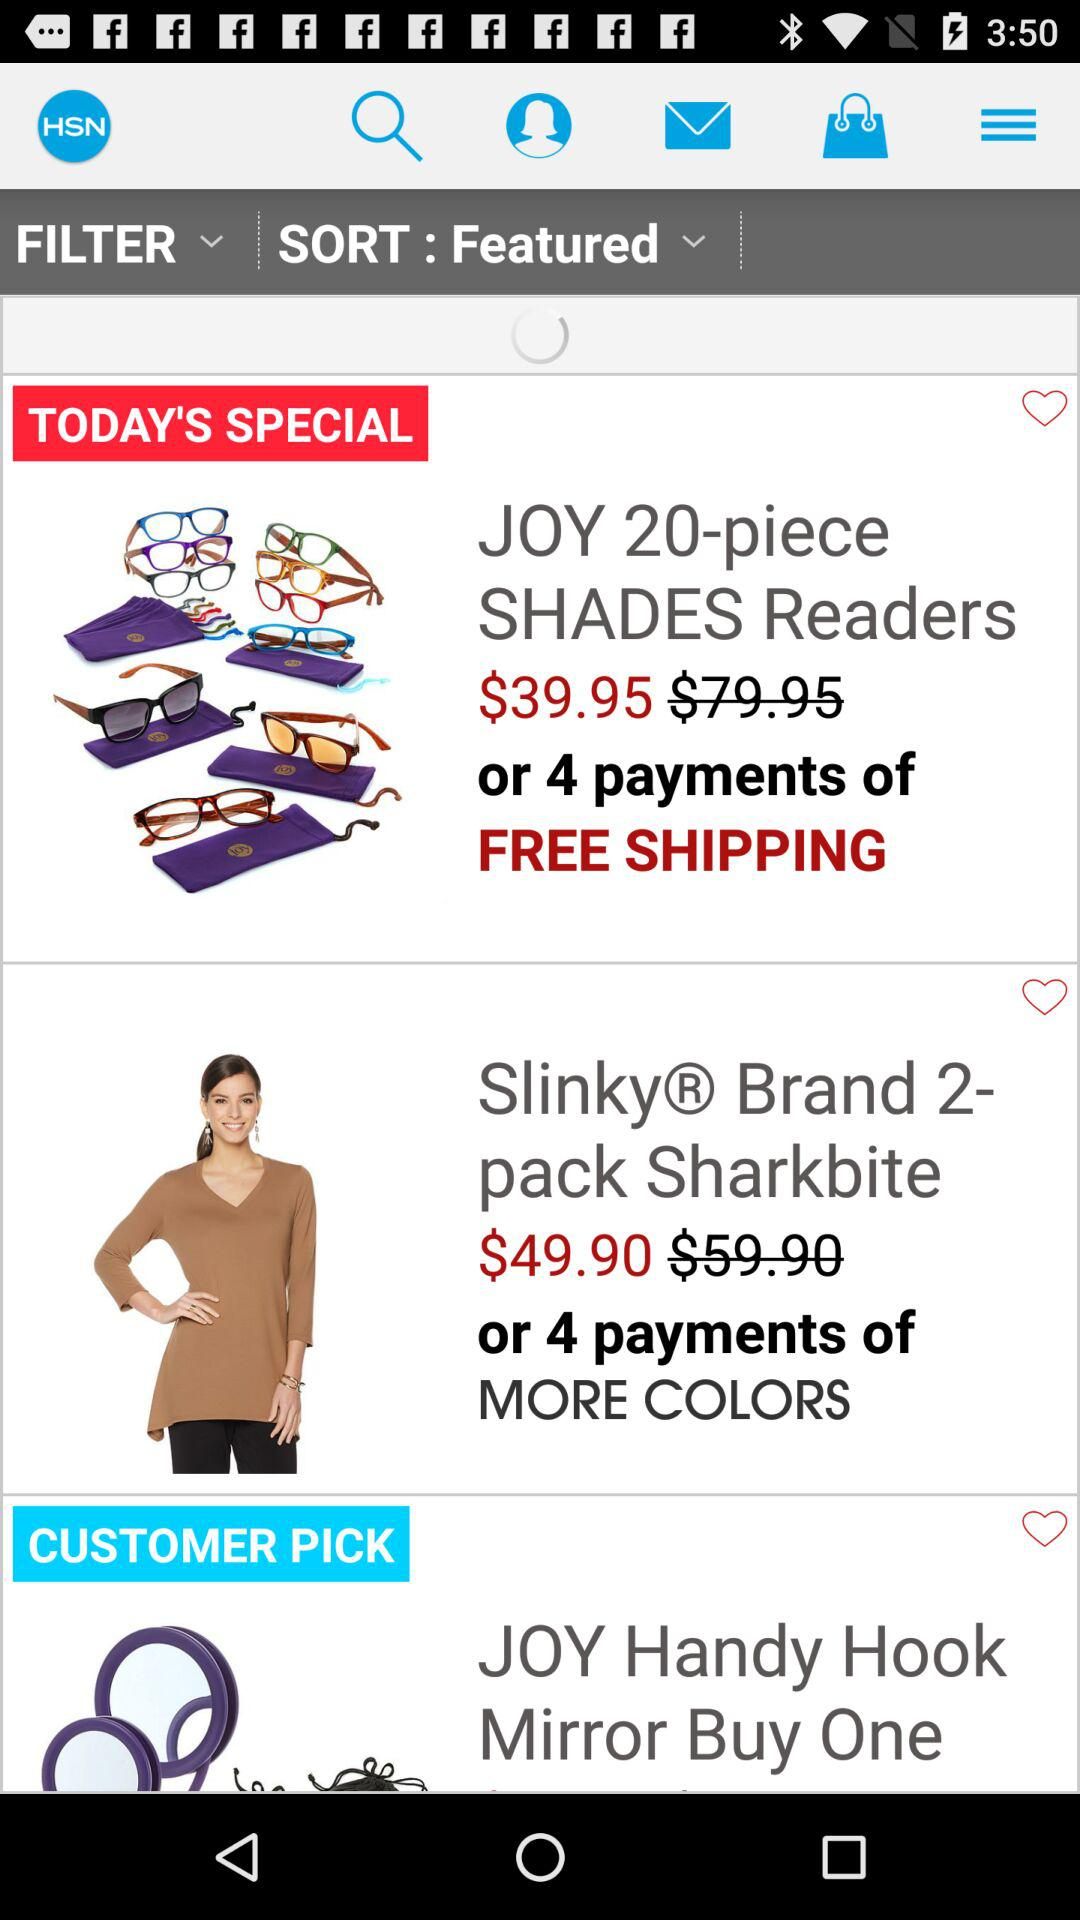What is the price of the Slinky® Brand 2-pack Sharkbite? The price is $49.90. 